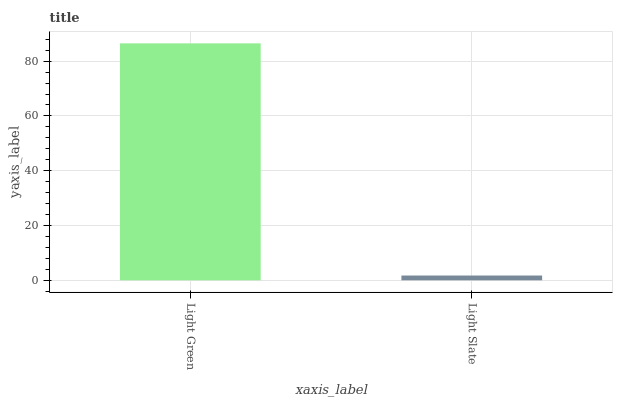Is Light Slate the maximum?
Answer yes or no. No. Is Light Green greater than Light Slate?
Answer yes or no. Yes. Is Light Slate less than Light Green?
Answer yes or no. Yes. Is Light Slate greater than Light Green?
Answer yes or no. No. Is Light Green less than Light Slate?
Answer yes or no. No. Is Light Green the high median?
Answer yes or no. Yes. Is Light Slate the low median?
Answer yes or no. Yes. Is Light Slate the high median?
Answer yes or no. No. Is Light Green the low median?
Answer yes or no. No. 